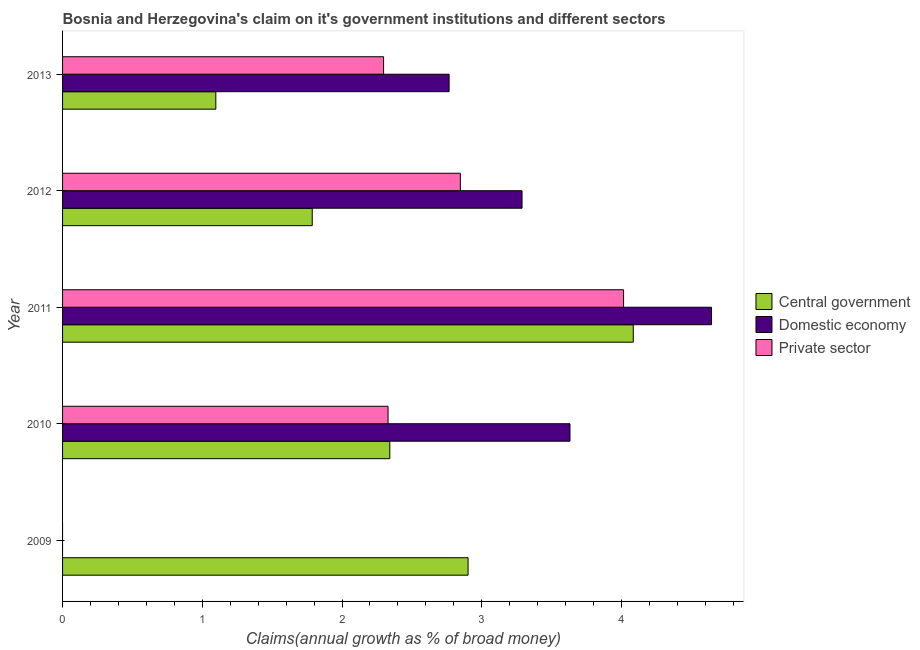How many different coloured bars are there?
Give a very brief answer. 3. Are the number of bars per tick equal to the number of legend labels?
Your answer should be compact. No. Are the number of bars on each tick of the Y-axis equal?
Provide a succinct answer. No. How many bars are there on the 4th tick from the top?
Make the answer very short. 3. In how many cases, is the number of bars for a given year not equal to the number of legend labels?
Your answer should be very brief. 1. What is the percentage of claim on the central government in 2010?
Ensure brevity in your answer.  2.34. Across all years, what is the maximum percentage of claim on the private sector?
Ensure brevity in your answer.  4.02. Across all years, what is the minimum percentage of claim on the private sector?
Keep it short and to the point. 0. In which year was the percentage of claim on the domestic economy maximum?
Make the answer very short. 2011. What is the total percentage of claim on the private sector in the graph?
Make the answer very short. 11.49. What is the difference between the percentage of claim on the central government in 2009 and that in 2012?
Offer a very short reply. 1.11. What is the difference between the percentage of claim on the central government in 2009 and the percentage of claim on the domestic economy in 2010?
Offer a very short reply. -0.73. What is the average percentage of claim on the private sector per year?
Offer a very short reply. 2.3. In the year 2013, what is the difference between the percentage of claim on the private sector and percentage of claim on the domestic economy?
Provide a succinct answer. -0.47. What is the ratio of the percentage of claim on the private sector in 2012 to that in 2013?
Give a very brief answer. 1.24. Is the difference between the percentage of claim on the central government in 2011 and 2013 greater than the difference between the percentage of claim on the domestic economy in 2011 and 2013?
Your response must be concise. Yes. What is the difference between the highest and the second highest percentage of claim on the domestic economy?
Offer a very short reply. 1.01. What is the difference between the highest and the lowest percentage of claim on the private sector?
Provide a succinct answer. 4.02. In how many years, is the percentage of claim on the central government greater than the average percentage of claim on the central government taken over all years?
Make the answer very short. 2. Is it the case that in every year, the sum of the percentage of claim on the central government and percentage of claim on the domestic economy is greater than the percentage of claim on the private sector?
Your response must be concise. Yes. How many bars are there?
Provide a short and direct response. 13. How many years are there in the graph?
Ensure brevity in your answer.  5. What is the difference between two consecutive major ticks on the X-axis?
Ensure brevity in your answer.  1. Are the values on the major ticks of X-axis written in scientific E-notation?
Your answer should be compact. No. Does the graph contain any zero values?
Offer a terse response. Yes. How many legend labels are there?
Provide a short and direct response. 3. How are the legend labels stacked?
Provide a short and direct response. Vertical. What is the title of the graph?
Your answer should be very brief. Bosnia and Herzegovina's claim on it's government institutions and different sectors. What is the label or title of the X-axis?
Your response must be concise. Claims(annual growth as % of broad money). What is the label or title of the Y-axis?
Offer a terse response. Year. What is the Claims(annual growth as % of broad money) in Central government in 2009?
Make the answer very short. 2.9. What is the Claims(annual growth as % of broad money) in Domestic economy in 2009?
Your response must be concise. 0. What is the Claims(annual growth as % of broad money) of Private sector in 2009?
Your response must be concise. 0. What is the Claims(annual growth as % of broad money) of Central government in 2010?
Ensure brevity in your answer.  2.34. What is the Claims(annual growth as % of broad money) in Domestic economy in 2010?
Offer a terse response. 3.63. What is the Claims(annual growth as % of broad money) in Private sector in 2010?
Ensure brevity in your answer.  2.33. What is the Claims(annual growth as % of broad money) in Central government in 2011?
Make the answer very short. 4.08. What is the Claims(annual growth as % of broad money) in Domestic economy in 2011?
Provide a succinct answer. 4.64. What is the Claims(annual growth as % of broad money) in Private sector in 2011?
Give a very brief answer. 4.02. What is the Claims(annual growth as % of broad money) in Central government in 2012?
Your response must be concise. 1.79. What is the Claims(annual growth as % of broad money) of Domestic economy in 2012?
Offer a very short reply. 3.29. What is the Claims(annual growth as % of broad money) in Private sector in 2012?
Provide a succinct answer. 2.85. What is the Claims(annual growth as % of broad money) of Central government in 2013?
Provide a short and direct response. 1.1. What is the Claims(annual growth as % of broad money) of Domestic economy in 2013?
Keep it short and to the point. 2.77. What is the Claims(annual growth as % of broad money) in Private sector in 2013?
Offer a very short reply. 2.3. Across all years, what is the maximum Claims(annual growth as % of broad money) of Central government?
Your answer should be very brief. 4.08. Across all years, what is the maximum Claims(annual growth as % of broad money) in Domestic economy?
Provide a succinct answer. 4.64. Across all years, what is the maximum Claims(annual growth as % of broad money) in Private sector?
Make the answer very short. 4.02. Across all years, what is the minimum Claims(annual growth as % of broad money) in Central government?
Provide a succinct answer. 1.1. Across all years, what is the minimum Claims(annual growth as % of broad money) in Domestic economy?
Your answer should be compact. 0. Across all years, what is the minimum Claims(annual growth as % of broad money) of Private sector?
Your answer should be compact. 0. What is the total Claims(annual growth as % of broad money) in Central government in the graph?
Offer a terse response. 12.21. What is the total Claims(annual growth as % of broad money) of Domestic economy in the graph?
Offer a terse response. 14.33. What is the total Claims(annual growth as % of broad money) of Private sector in the graph?
Offer a terse response. 11.49. What is the difference between the Claims(annual growth as % of broad money) of Central government in 2009 and that in 2010?
Ensure brevity in your answer.  0.56. What is the difference between the Claims(annual growth as % of broad money) in Central government in 2009 and that in 2011?
Provide a succinct answer. -1.18. What is the difference between the Claims(annual growth as % of broad money) of Central government in 2009 and that in 2012?
Provide a short and direct response. 1.12. What is the difference between the Claims(annual growth as % of broad money) of Central government in 2009 and that in 2013?
Your answer should be very brief. 1.81. What is the difference between the Claims(annual growth as % of broad money) of Central government in 2010 and that in 2011?
Provide a succinct answer. -1.74. What is the difference between the Claims(annual growth as % of broad money) in Domestic economy in 2010 and that in 2011?
Make the answer very short. -1.01. What is the difference between the Claims(annual growth as % of broad money) of Private sector in 2010 and that in 2011?
Your answer should be compact. -1.69. What is the difference between the Claims(annual growth as % of broad money) in Central government in 2010 and that in 2012?
Give a very brief answer. 0.56. What is the difference between the Claims(annual growth as % of broad money) of Domestic economy in 2010 and that in 2012?
Make the answer very short. 0.34. What is the difference between the Claims(annual growth as % of broad money) of Private sector in 2010 and that in 2012?
Your response must be concise. -0.52. What is the difference between the Claims(annual growth as % of broad money) of Central government in 2010 and that in 2013?
Your answer should be compact. 1.25. What is the difference between the Claims(annual growth as % of broad money) in Domestic economy in 2010 and that in 2013?
Make the answer very short. 0.86. What is the difference between the Claims(annual growth as % of broad money) in Private sector in 2010 and that in 2013?
Offer a terse response. 0.03. What is the difference between the Claims(annual growth as % of broad money) of Central government in 2011 and that in 2012?
Your response must be concise. 2.3. What is the difference between the Claims(annual growth as % of broad money) in Domestic economy in 2011 and that in 2012?
Give a very brief answer. 1.36. What is the difference between the Claims(annual growth as % of broad money) in Private sector in 2011 and that in 2012?
Make the answer very short. 1.17. What is the difference between the Claims(annual growth as % of broad money) of Central government in 2011 and that in 2013?
Provide a short and direct response. 2.99. What is the difference between the Claims(annual growth as % of broad money) in Domestic economy in 2011 and that in 2013?
Your answer should be compact. 1.88. What is the difference between the Claims(annual growth as % of broad money) of Private sector in 2011 and that in 2013?
Ensure brevity in your answer.  1.72. What is the difference between the Claims(annual growth as % of broad money) in Central government in 2012 and that in 2013?
Your answer should be very brief. 0.69. What is the difference between the Claims(annual growth as % of broad money) of Domestic economy in 2012 and that in 2013?
Offer a very short reply. 0.52. What is the difference between the Claims(annual growth as % of broad money) in Private sector in 2012 and that in 2013?
Make the answer very short. 0.55. What is the difference between the Claims(annual growth as % of broad money) in Central government in 2009 and the Claims(annual growth as % of broad money) in Domestic economy in 2010?
Provide a short and direct response. -0.73. What is the difference between the Claims(annual growth as % of broad money) in Central government in 2009 and the Claims(annual growth as % of broad money) in Private sector in 2010?
Your response must be concise. 0.57. What is the difference between the Claims(annual growth as % of broad money) of Central government in 2009 and the Claims(annual growth as % of broad money) of Domestic economy in 2011?
Offer a very short reply. -1.74. What is the difference between the Claims(annual growth as % of broad money) of Central government in 2009 and the Claims(annual growth as % of broad money) of Private sector in 2011?
Offer a very short reply. -1.11. What is the difference between the Claims(annual growth as % of broad money) of Central government in 2009 and the Claims(annual growth as % of broad money) of Domestic economy in 2012?
Your response must be concise. -0.39. What is the difference between the Claims(annual growth as % of broad money) of Central government in 2009 and the Claims(annual growth as % of broad money) of Private sector in 2012?
Provide a short and direct response. 0.06. What is the difference between the Claims(annual growth as % of broad money) in Central government in 2009 and the Claims(annual growth as % of broad money) in Domestic economy in 2013?
Ensure brevity in your answer.  0.14. What is the difference between the Claims(annual growth as % of broad money) of Central government in 2009 and the Claims(annual growth as % of broad money) of Private sector in 2013?
Ensure brevity in your answer.  0.6. What is the difference between the Claims(annual growth as % of broad money) of Central government in 2010 and the Claims(annual growth as % of broad money) of Domestic economy in 2011?
Offer a terse response. -2.3. What is the difference between the Claims(annual growth as % of broad money) in Central government in 2010 and the Claims(annual growth as % of broad money) in Private sector in 2011?
Offer a terse response. -1.67. What is the difference between the Claims(annual growth as % of broad money) in Domestic economy in 2010 and the Claims(annual growth as % of broad money) in Private sector in 2011?
Make the answer very short. -0.38. What is the difference between the Claims(annual growth as % of broad money) of Central government in 2010 and the Claims(annual growth as % of broad money) of Domestic economy in 2012?
Offer a very short reply. -0.95. What is the difference between the Claims(annual growth as % of broad money) of Central government in 2010 and the Claims(annual growth as % of broad money) of Private sector in 2012?
Offer a very short reply. -0.5. What is the difference between the Claims(annual growth as % of broad money) of Domestic economy in 2010 and the Claims(annual growth as % of broad money) of Private sector in 2012?
Provide a short and direct response. 0.78. What is the difference between the Claims(annual growth as % of broad money) of Central government in 2010 and the Claims(annual growth as % of broad money) of Domestic economy in 2013?
Your response must be concise. -0.42. What is the difference between the Claims(annual growth as % of broad money) in Central government in 2010 and the Claims(annual growth as % of broad money) in Private sector in 2013?
Provide a short and direct response. 0.04. What is the difference between the Claims(annual growth as % of broad money) in Domestic economy in 2010 and the Claims(annual growth as % of broad money) in Private sector in 2013?
Offer a terse response. 1.33. What is the difference between the Claims(annual growth as % of broad money) in Central government in 2011 and the Claims(annual growth as % of broad money) in Domestic economy in 2012?
Give a very brief answer. 0.8. What is the difference between the Claims(annual growth as % of broad money) in Central government in 2011 and the Claims(annual growth as % of broad money) in Private sector in 2012?
Your answer should be compact. 1.24. What is the difference between the Claims(annual growth as % of broad money) in Domestic economy in 2011 and the Claims(annual growth as % of broad money) in Private sector in 2012?
Provide a succinct answer. 1.8. What is the difference between the Claims(annual growth as % of broad money) in Central government in 2011 and the Claims(annual growth as % of broad money) in Domestic economy in 2013?
Your answer should be very brief. 1.32. What is the difference between the Claims(annual growth as % of broad money) in Central government in 2011 and the Claims(annual growth as % of broad money) in Private sector in 2013?
Offer a very short reply. 1.79. What is the difference between the Claims(annual growth as % of broad money) in Domestic economy in 2011 and the Claims(annual growth as % of broad money) in Private sector in 2013?
Make the answer very short. 2.35. What is the difference between the Claims(annual growth as % of broad money) in Central government in 2012 and the Claims(annual growth as % of broad money) in Domestic economy in 2013?
Provide a succinct answer. -0.98. What is the difference between the Claims(annual growth as % of broad money) of Central government in 2012 and the Claims(annual growth as % of broad money) of Private sector in 2013?
Keep it short and to the point. -0.51. What is the difference between the Claims(annual growth as % of broad money) in Domestic economy in 2012 and the Claims(annual growth as % of broad money) in Private sector in 2013?
Your answer should be very brief. 0.99. What is the average Claims(annual growth as % of broad money) of Central government per year?
Your response must be concise. 2.44. What is the average Claims(annual growth as % of broad money) in Domestic economy per year?
Ensure brevity in your answer.  2.87. What is the average Claims(annual growth as % of broad money) of Private sector per year?
Your answer should be very brief. 2.3. In the year 2010, what is the difference between the Claims(annual growth as % of broad money) of Central government and Claims(annual growth as % of broad money) of Domestic economy?
Your response must be concise. -1.29. In the year 2010, what is the difference between the Claims(annual growth as % of broad money) in Central government and Claims(annual growth as % of broad money) in Private sector?
Offer a terse response. 0.01. In the year 2010, what is the difference between the Claims(annual growth as % of broad money) in Domestic economy and Claims(annual growth as % of broad money) in Private sector?
Your answer should be compact. 1.3. In the year 2011, what is the difference between the Claims(annual growth as % of broad money) of Central government and Claims(annual growth as % of broad money) of Domestic economy?
Your answer should be very brief. -0.56. In the year 2011, what is the difference between the Claims(annual growth as % of broad money) in Central government and Claims(annual growth as % of broad money) in Private sector?
Your response must be concise. 0.07. In the year 2011, what is the difference between the Claims(annual growth as % of broad money) in Domestic economy and Claims(annual growth as % of broad money) in Private sector?
Keep it short and to the point. 0.63. In the year 2012, what is the difference between the Claims(annual growth as % of broad money) of Central government and Claims(annual growth as % of broad money) of Domestic economy?
Your answer should be very brief. -1.5. In the year 2012, what is the difference between the Claims(annual growth as % of broad money) in Central government and Claims(annual growth as % of broad money) in Private sector?
Keep it short and to the point. -1.06. In the year 2012, what is the difference between the Claims(annual growth as % of broad money) in Domestic economy and Claims(annual growth as % of broad money) in Private sector?
Offer a very short reply. 0.44. In the year 2013, what is the difference between the Claims(annual growth as % of broad money) of Central government and Claims(annual growth as % of broad money) of Domestic economy?
Your response must be concise. -1.67. In the year 2013, what is the difference between the Claims(annual growth as % of broad money) of Central government and Claims(annual growth as % of broad money) of Private sector?
Give a very brief answer. -1.2. In the year 2013, what is the difference between the Claims(annual growth as % of broad money) of Domestic economy and Claims(annual growth as % of broad money) of Private sector?
Your response must be concise. 0.47. What is the ratio of the Claims(annual growth as % of broad money) of Central government in 2009 to that in 2010?
Your answer should be very brief. 1.24. What is the ratio of the Claims(annual growth as % of broad money) in Central government in 2009 to that in 2011?
Keep it short and to the point. 0.71. What is the ratio of the Claims(annual growth as % of broad money) of Central government in 2009 to that in 2012?
Offer a terse response. 1.62. What is the ratio of the Claims(annual growth as % of broad money) in Central government in 2009 to that in 2013?
Make the answer very short. 2.65. What is the ratio of the Claims(annual growth as % of broad money) of Central government in 2010 to that in 2011?
Offer a very short reply. 0.57. What is the ratio of the Claims(annual growth as % of broad money) of Domestic economy in 2010 to that in 2011?
Your answer should be compact. 0.78. What is the ratio of the Claims(annual growth as % of broad money) in Private sector in 2010 to that in 2011?
Keep it short and to the point. 0.58. What is the ratio of the Claims(annual growth as % of broad money) of Central government in 2010 to that in 2012?
Your answer should be very brief. 1.31. What is the ratio of the Claims(annual growth as % of broad money) of Domestic economy in 2010 to that in 2012?
Your answer should be very brief. 1.1. What is the ratio of the Claims(annual growth as % of broad money) in Private sector in 2010 to that in 2012?
Make the answer very short. 0.82. What is the ratio of the Claims(annual growth as % of broad money) in Central government in 2010 to that in 2013?
Offer a terse response. 2.14. What is the ratio of the Claims(annual growth as % of broad money) in Domestic economy in 2010 to that in 2013?
Give a very brief answer. 1.31. What is the ratio of the Claims(annual growth as % of broad money) of Private sector in 2010 to that in 2013?
Keep it short and to the point. 1.01. What is the ratio of the Claims(annual growth as % of broad money) in Central government in 2011 to that in 2012?
Keep it short and to the point. 2.29. What is the ratio of the Claims(annual growth as % of broad money) of Domestic economy in 2011 to that in 2012?
Ensure brevity in your answer.  1.41. What is the ratio of the Claims(annual growth as % of broad money) of Private sector in 2011 to that in 2012?
Your answer should be compact. 1.41. What is the ratio of the Claims(annual growth as % of broad money) in Central government in 2011 to that in 2013?
Your response must be concise. 3.72. What is the ratio of the Claims(annual growth as % of broad money) of Domestic economy in 2011 to that in 2013?
Provide a short and direct response. 1.68. What is the ratio of the Claims(annual growth as % of broad money) of Private sector in 2011 to that in 2013?
Offer a terse response. 1.75. What is the ratio of the Claims(annual growth as % of broad money) in Central government in 2012 to that in 2013?
Keep it short and to the point. 1.63. What is the ratio of the Claims(annual growth as % of broad money) of Domestic economy in 2012 to that in 2013?
Offer a terse response. 1.19. What is the ratio of the Claims(annual growth as % of broad money) of Private sector in 2012 to that in 2013?
Give a very brief answer. 1.24. What is the difference between the highest and the second highest Claims(annual growth as % of broad money) of Central government?
Keep it short and to the point. 1.18. What is the difference between the highest and the second highest Claims(annual growth as % of broad money) of Domestic economy?
Provide a succinct answer. 1.01. What is the difference between the highest and the second highest Claims(annual growth as % of broad money) of Private sector?
Give a very brief answer. 1.17. What is the difference between the highest and the lowest Claims(annual growth as % of broad money) in Central government?
Provide a succinct answer. 2.99. What is the difference between the highest and the lowest Claims(annual growth as % of broad money) of Domestic economy?
Give a very brief answer. 4.64. What is the difference between the highest and the lowest Claims(annual growth as % of broad money) of Private sector?
Provide a short and direct response. 4.02. 